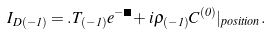Convert formula to latex. <formula><loc_0><loc_0><loc_500><loc_500>I _ { D ( - 1 ) } = . T _ { ( - 1 ) } e ^ { - \Phi } + i \rho _ { ( - 1 ) } C ^ { ( 0 ) } | _ { p o s i t i o n } .</formula> 